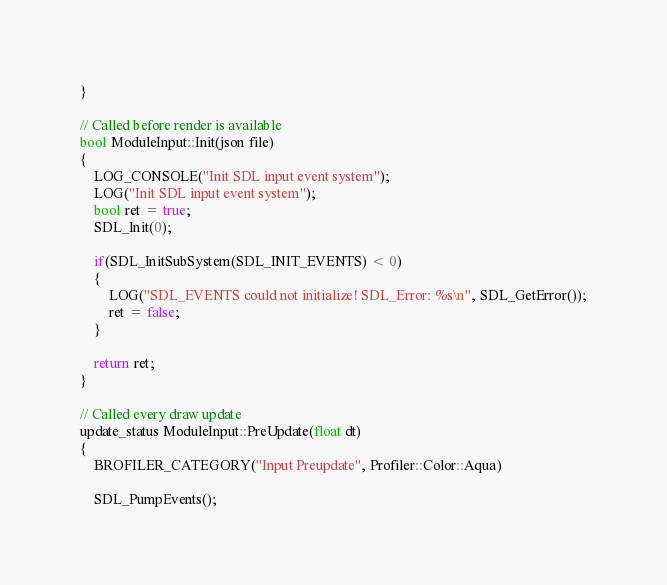Convert code to text. <code><loc_0><loc_0><loc_500><loc_500><_C++_>}

// Called before render is available
bool ModuleInput::Init(json file)
{
	LOG_CONSOLE("Init SDL input event system");
	LOG("Init SDL input event system");
	bool ret = true;
	SDL_Init(0);

	if(SDL_InitSubSystem(SDL_INIT_EVENTS) < 0)
	{
		LOG("SDL_EVENTS could not initialize! SDL_Error: %s\n", SDL_GetError());
		ret = false;
	}

	return ret;
}

// Called every draw update
update_status ModuleInput::PreUpdate(float dt)
{
	BROFILER_CATEGORY("Input Preupdate", Profiler::Color::Aqua)

	SDL_PumpEvents();
</code> 